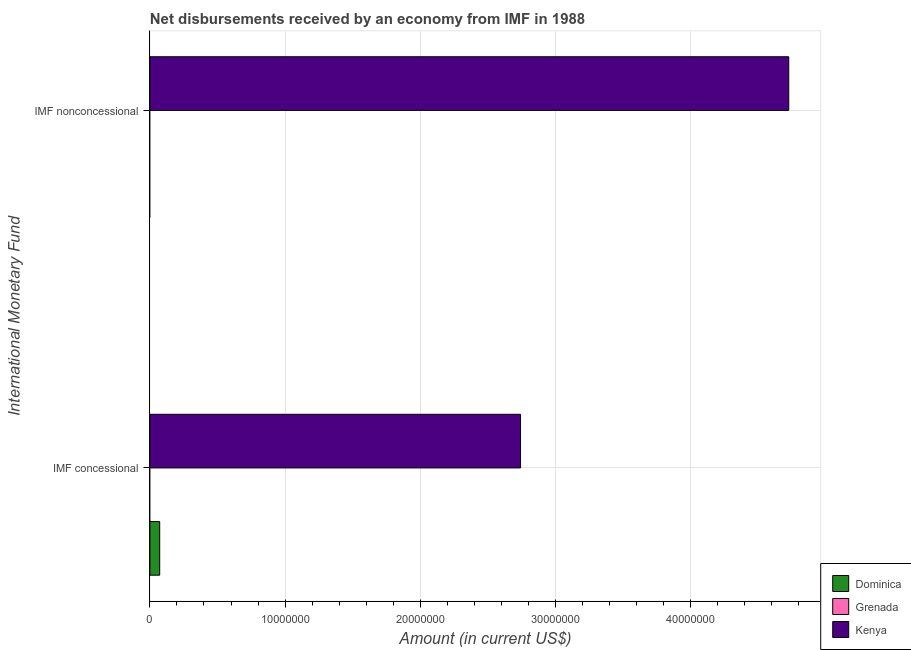How many different coloured bars are there?
Keep it short and to the point. 2. Are the number of bars on each tick of the Y-axis equal?
Keep it short and to the point. No. How many bars are there on the 1st tick from the top?
Ensure brevity in your answer.  1. What is the label of the 1st group of bars from the top?
Your answer should be very brief. IMF nonconcessional. What is the net non concessional disbursements from imf in Dominica?
Provide a succinct answer. 0. Across all countries, what is the maximum net concessional disbursements from imf?
Offer a terse response. 2.74e+07. Across all countries, what is the minimum net non concessional disbursements from imf?
Your answer should be compact. 0. In which country was the net concessional disbursements from imf maximum?
Keep it short and to the point. Kenya. What is the total net concessional disbursements from imf in the graph?
Your answer should be very brief. 2.81e+07. What is the difference between the net concessional disbursements from imf in Kenya and that in Dominica?
Make the answer very short. 2.67e+07. What is the difference between the net non concessional disbursements from imf in Dominica and the net concessional disbursements from imf in Grenada?
Ensure brevity in your answer.  0. What is the average net concessional disbursements from imf per country?
Make the answer very short. 9.38e+06. What is the difference between the net concessional disbursements from imf and net non concessional disbursements from imf in Kenya?
Keep it short and to the point. -1.98e+07. In how many countries, is the net non concessional disbursements from imf greater than 2000000 US$?
Make the answer very short. 1. Is the net concessional disbursements from imf in Dominica less than that in Kenya?
Keep it short and to the point. Yes. How many bars are there?
Your answer should be very brief. 3. Does the graph contain any zero values?
Provide a succinct answer. Yes. What is the title of the graph?
Give a very brief answer. Net disbursements received by an economy from IMF in 1988. What is the label or title of the Y-axis?
Make the answer very short. International Monetary Fund. What is the Amount (in current US$) in Dominica in IMF concessional?
Ensure brevity in your answer.  7.26e+05. What is the Amount (in current US$) in Grenada in IMF concessional?
Keep it short and to the point. 0. What is the Amount (in current US$) in Kenya in IMF concessional?
Offer a very short reply. 2.74e+07. What is the Amount (in current US$) of Kenya in IMF nonconcessional?
Provide a succinct answer. 4.73e+07. Across all International Monetary Fund, what is the maximum Amount (in current US$) of Dominica?
Make the answer very short. 7.26e+05. Across all International Monetary Fund, what is the maximum Amount (in current US$) in Kenya?
Your response must be concise. 4.73e+07. Across all International Monetary Fund, what is the minimum Amount (in current US$) in Dominica?
Give a very brief answer. 0. Across all International Monetary Fund, what is the minimum Amount (in current US$) of Kenya?
Offer a terse response. 2.74e+07. What is the total Amount (in current US$) in Dominica in the graph?
Your answer should be compact. 7.26e+05. What is the total Amount (in current US$) in Grenada in the graph?
Your answer should be very brief. 0. What is the total Amount (in current US$) of Kenya in the graph?
Offer a terse response. 7.47e+07. What is the difference between the Amount (in current US$) of Kenya in IMF concessional and that in IMF nonconcessional?
Your answer should be compact. -1.98e+07. What is the difference between the Amount (in current US$) in Dominica in IMF concessional and the Amount (in current US$) in Kenya in IMF nonconcessional?
Your answer should be compact. -4.65e+07. What is the average Amount (in current US$) of Dominica per International Monetary Fund?
Provide a succinct answer. 3.63e+05. What is the average Amount (in current US$) in Grenada per International Monetary Fund?
Provide a succinct answer. 0. What is the average Amount (in current US$) in Kenya per International Monetary Fund?
Offer a terse response. 3.73e+07. What is the difference between the Amount (in current US$) of Dominica and Amount (in current US$) of Kenya in IMF concessional?
Offer a very short reply. -2.67e+07. What is the ratio of the Amount (in current US$) of Kenya in IMF concessional to that in IMF nonconcessional?
Your response must be concise. 0.58. What is the difference between the highest and the second highest Amount (in current US$) in Kenya?
Your answer should be compact. 1.98e+07. What is the difference between the highest and the lowest Amount (in current US$) in Dominica?
Offer a terse response. 7.26e+05. What is the difference between the highest and the lowest Amount (in current US$) in Kenya?
Offer a very short reply. 1.98e+07. 